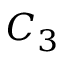<formula> <loc_0><loc_0><loc_500><loc_500>C _ { 3 }</formula> 